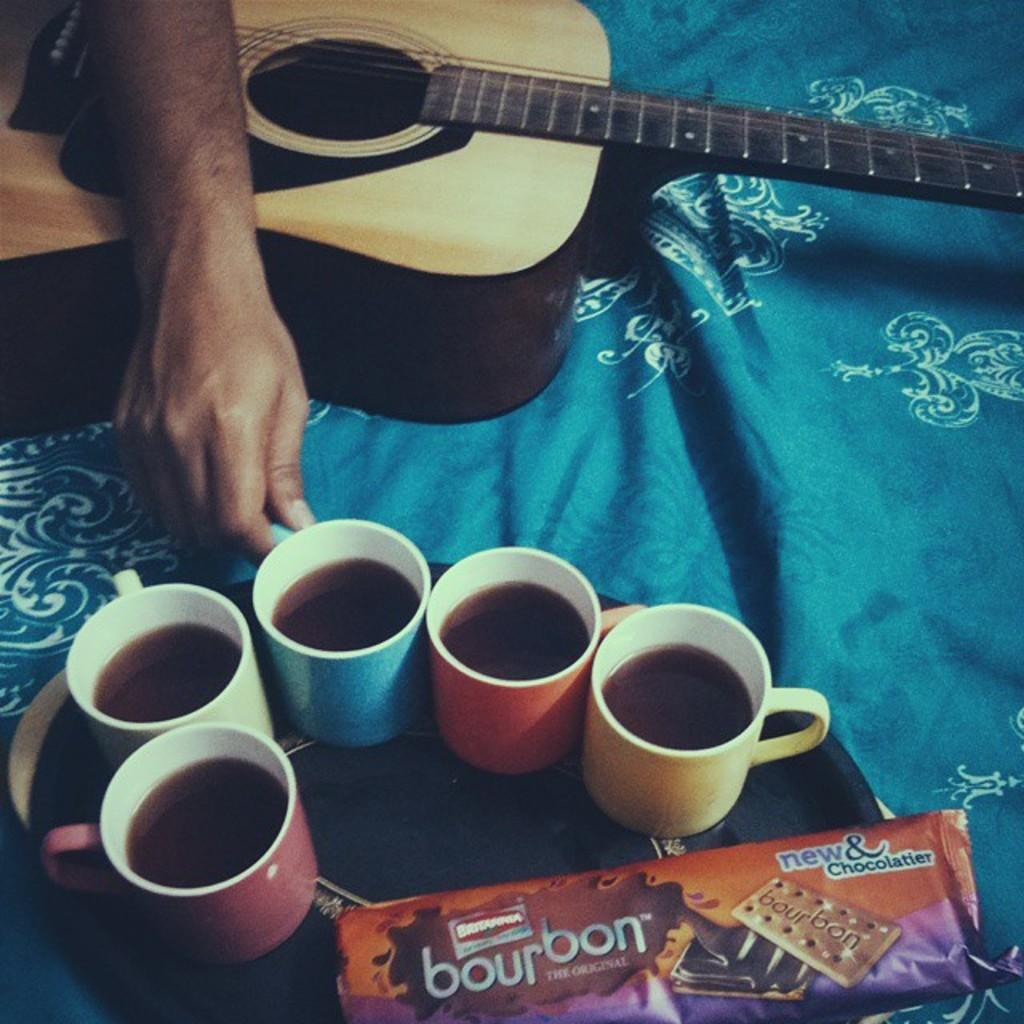What is in the cups that are visible in the image? There are cups with coffee in the image. What else can be seen on the tray besides the cups? There is a biscuit packet on the tray. What musical instrument is present in the image? There is a guitar in the image. Who is holding a cup in the image? A person is holding a cup. What type of material is present in the image? There is a cloth in the image. How many dogs are sitting on the guitar in the image? There are no dogs present in the image, and therefore no dogs are sitting on the guitar. What part of the person's body is shown holding the cup in the image? The provided facts do not specify which part of the person's body is holding the cup, only that a person is holding a cup. 